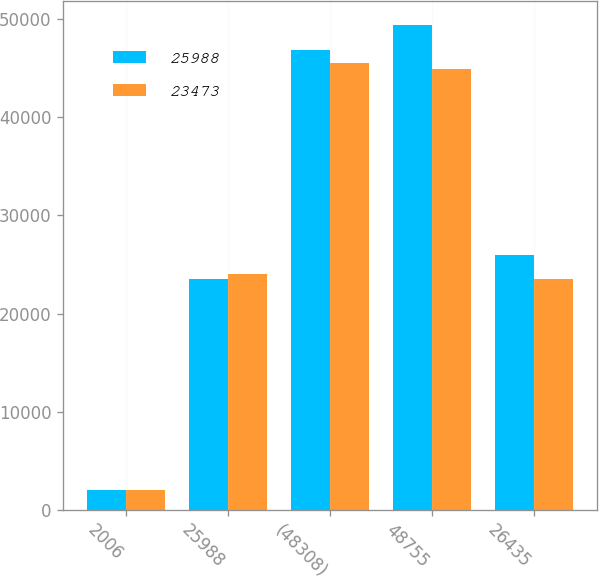<chart> <loc_0><loc_0><loc_500><loc_500><stacked_bar_chart><ecel><fcel>2006<fcel>25988<fcel>(48308)<fcel>48755<fcel>26435<nl><fcel>25988<fcel>2005<fcel>23473<fcel>46850<fcel>49365<fcel>25988<nl><fcel>23473<fcel>2004<fcel>24063<fcel>45553<fcel>44963<fcel>23473<nl></chart> 